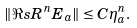Convert formula to latex. <formula><loc_0><loc_0><loc_500><loc_500>\| \Re s { R ^ { n } } { E _ { a } } \| \leq C \eta _ { a } ^ { n } .</formula> 